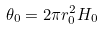<formula> <loc_0><loc_0><loc_500><loc_500>\theta _ { 0 } = 2 \pi r _ { 0 } ^ { 2 } H _ { 0 }</formula> 